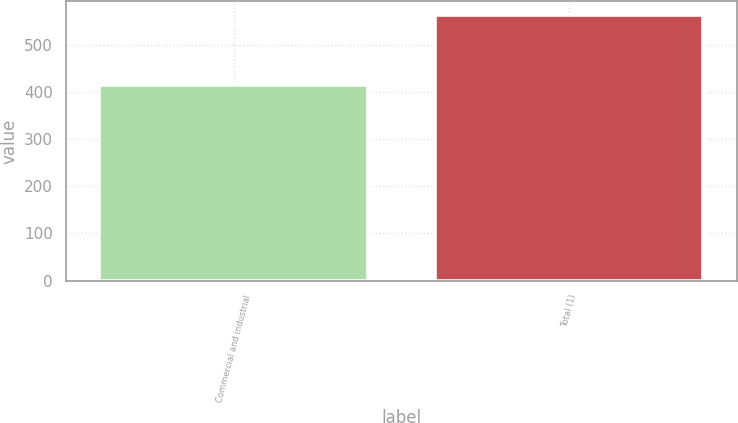<chart> <loc_0><loc_0><loc_500><loc_500><bar_chart><fcel>Commercial and industrial<fcel>Total (1)<nl><fcel>414<fcel>564<nl></chart> 